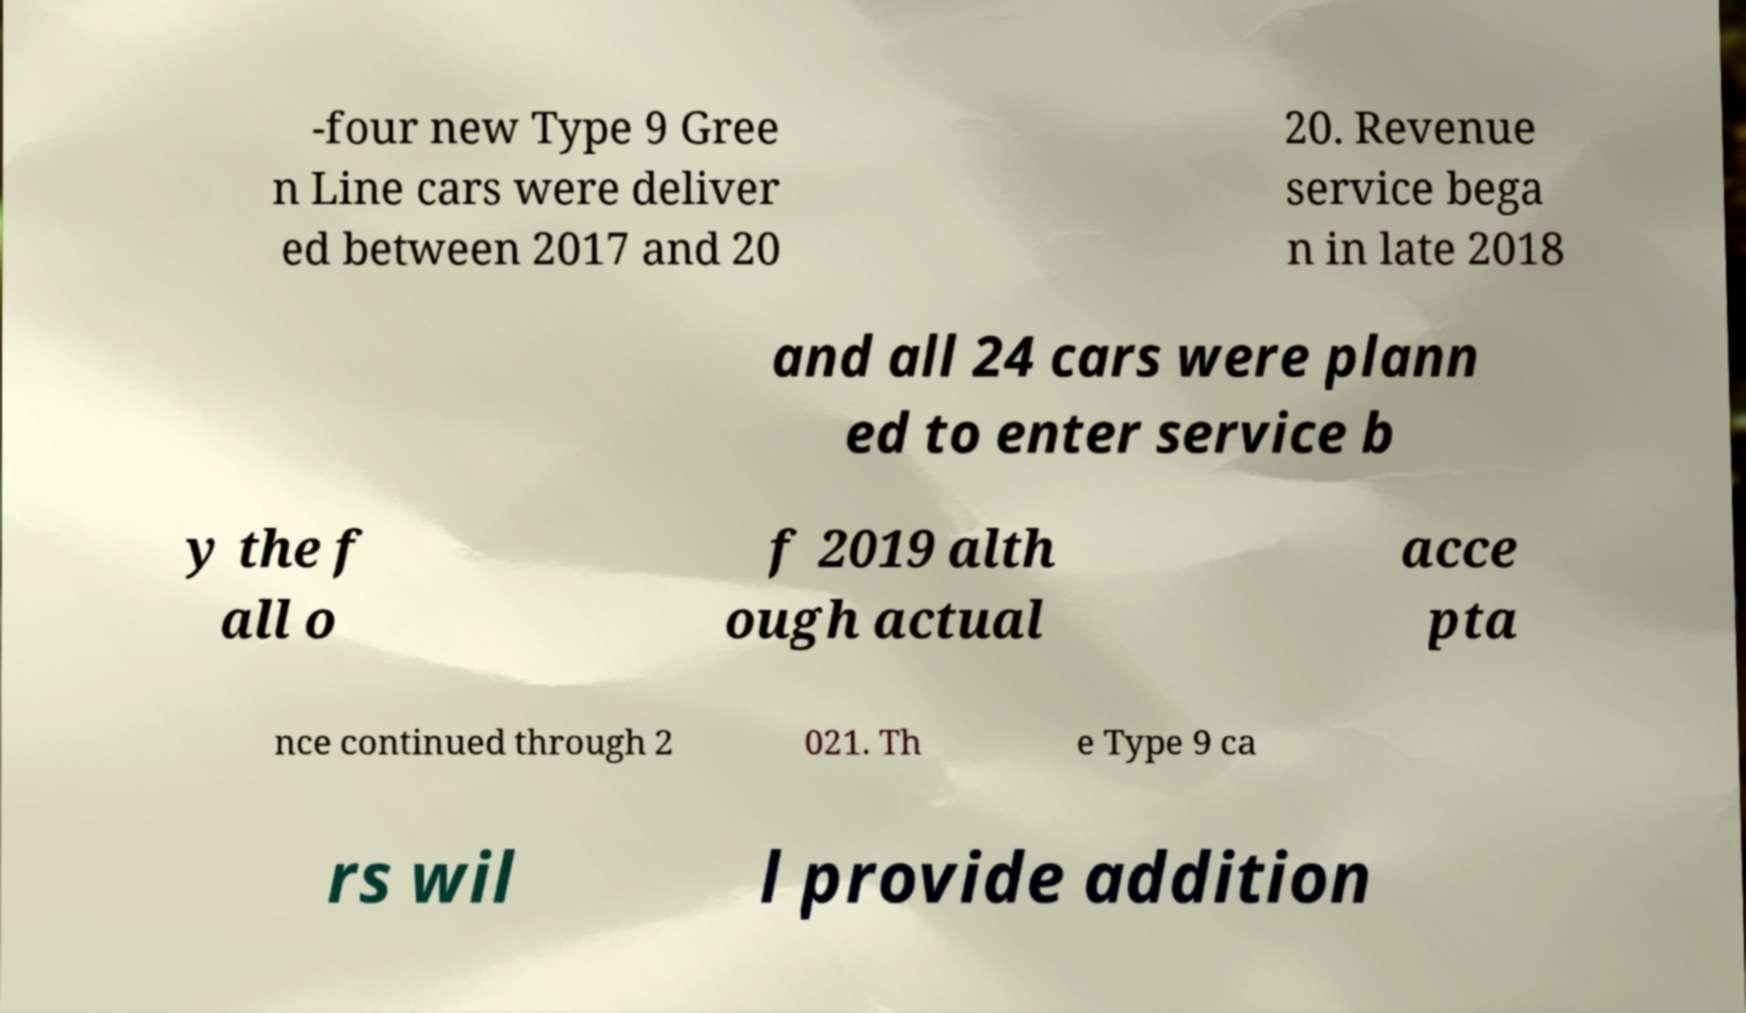Can you read and provide the text displayed in the image?This photo seems to have some interesting text. Can you extract and type it out for me? -four new Type 9 Gree n Line cars were deliver ed between 2017 and 20 20. Revenue service bega n in late 2018 and all 24 cars were plann ed to enter service b y the f all o f 2019 alth ough actual acce pta nce continued through 2 021. Th e Type 9 ca rs wil l provide addition 